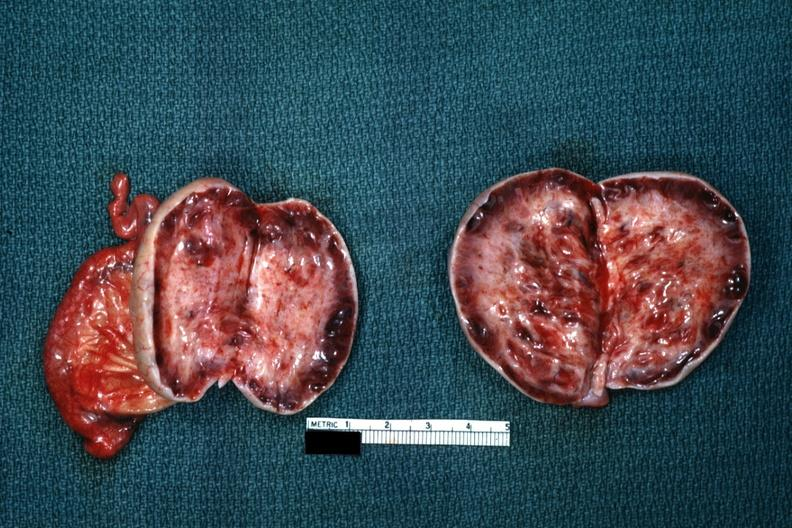how does this image show thick capsule?
Answer the question using a single word or phrase. With some cysts 